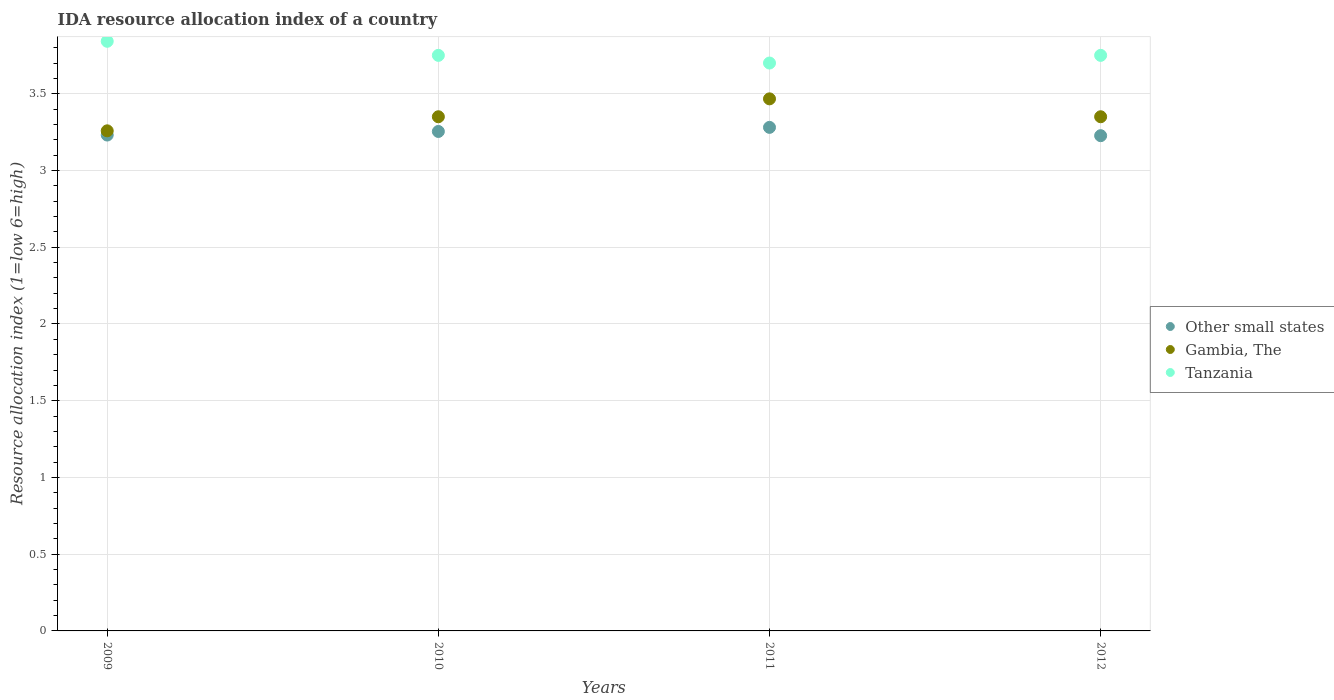Is the number of dotlines equal to the number of legend labels?
Make the answer very short. Yes. What is the IDA resource allocation index in Other small states in 2012?
Offer a terse response. 3.23. Across all years, what is the maximum IDA resource allocation index in Other small states?
Offer a terse response. 3.28. Across all years, what is the minimum IDA resource allocation index in Gambia, The?
Your response must be concise. 3.26. In which year was the IDA resource allocation index in Gambia, The maximum?
Your answer should be compact. 2011. What is the total IDA resource allocation index in Gambia, The in the graph?
Your response must be concise. 13.43. What is the difference between the IDA resource allocation index in Other small states in 2010 and that in 2012?
Provide a succinct answer. 0.03. What is the difference between the IDA resource allocation index in Gambia, The in 2011 and the IDA resource allocation index in Other small states in 2012?
Your response must be concise. 0.24. What is the average IDA resource allocation index in Other small states per year?
Make the answer very short. 3.25. In the year 2010, what is the difference between the IDA resource allocation index in Tanzania and IDA resource allocation index in Other small states?
Keep it short and to the point. 0.5. In how many years, is the IDA resource allocation index in Gambia, The greater than 3.5?
Provide a short and direct response. 0. What is the ratio of the IDA resource allocation index in Tanzania in 2009 to that in 2011?
Your answer should be compact. 1.04. Is the IDA resource allocation index in Tanzania in 2011 less than that in 2012?
Keep it short and to the point. Yes. Is the difference between the IDA resource allocation index in Tanzania in 2009 and 2012 greater than the difference between the IDA resource allocation index in Other small states in 2009 and 2012?
Provide a short and direct response. Yes. What is the difference between the highest and the second highest IDA resource allocation index in Gambia, The?
Your answer should be very brief. 0.12. What is the difference between the highest and the lowest IDA resource allocation index in Tanzania?
Keep it short and to the point. 0.14. In how many years, is the IDA resource allocation index in Other small states greater than the average IDA resource allocation index in Other small states taken over all years?
Keep it short and to the point. 2. Is it the case that in every year, the sum of the IDA resource allocation index in Tanzania and IDA resource allocation index in Other small states  is greater than the IDA resource allocation index in Gambia, The?
Keep it short and to the point. Yes. Is the IDA resource allocation index in Other small states strictly greater than the IDA resource allocation index in Tanzania over the years?
Offer a very short reply. No. Is the IDA resource allocation index in Other small states strictly less than the IDA resource allocation index in Gambia, The over the years?
Offer a very short reply. Yes. How many dotlines are there?
Your answer should be compact. 3. How many years are there in the graph?
Give a very brief answer. 4. What is the difference between two consecutive major ticks on the Y-axis?
Make the answer very short. 0.5. Are the values on the major ticks of Y-axis written in scientific E-notation?
Offer a very short reply. No. Does the graph contain any zero values?
Make the answer very short. No. Where does the legend appear in the graph?
Offer a terse response. Center right. How many legend labels are there?
Make the answer very short. 3. How are the legend labels stacked?
Offer a terse response. Vertical. What is the title of the graph?
Keep it short and to the point. IDA resource allocation index of a country. Does "Pacific island small states" appear as one of the legend labels in the graph?
Your response must be concise. No. What is the label or title of the Y-axis?
Give a very brief answer. Resource allocation index (1=low 6=high). What is the Resource allocation index (1=low 6=high) of Other small states in 2009?
Give a very brief answer. 3.23. What is the Resource allocation index (1=low 6=high) of Gambia, The in 2009?
Ensure brevity in your answer.  3.26. What is the Resource allocation index (1=low 6=high) in Tanzania in 2009?
Keep it short and to the point. 3.84. What is the Resource allocation index (1=low 6=high) in Other small states in 2010?
Provide a short and direct response. 3.25. What is the Resource allocation index (1=low 6=high) of Gambia, The in 2010?
Make the answer very short. 3.35. What is the Resource allocation index (1=low 6=high) in Tanzania in 2010?
Offer a very short reply. 3.75. What is the Resource allocation index (1=low 6=high) in Other small states in 2011?
Offer a terse response. 3.28. What is the Resource allocation index (1=low 6=high) of Gambia, The in 2011?
Provide a short and direct response. 3.47. What is the Resource allocation index (1=low 6=high) of Tanzania in 2011?
Offer a terse response. 3.7. What is the Resource allocation index (1=low 6=high) of Other small states in 2012?
Make the answer very short. 3.23. What is the Resource allocation index (1=low 6=high) of Gambia, The in 2012?
Your answer should be compact. 3.35. What is the Resource allocation index (1=low 6=high) in Tanzania in 2012?
Ensure brevity in your answer.  3.75. Across all years, what is the maximum Resource allocation index (1=low 6=high) in Other small states?
Make the answer very short. 3.28. Across all years, what is the maximum Resource allocation index (1=low 6=high) in Gambia, The?
Make the answer very short. 3.47. Across all years, what is the maximum Resource allocation index (1=low 6=high) of Tanzania?
Ensure brevity in your answer.  3.84. Across all years, what is the minimum Resource allocation index (1=low 6=high) in Other small states?
Provide a succinct answer. 3.23. Across all years, what is the minimum Resource allocation index (1=low 6=high) in Gambia, The?
Keep it short and to the point. 3.26. What is the total Resource allocation index (1=low 6=high) in Other small states in the graph?
Offer a terse response. 12.99. What is the total Resource allocation index (1=low 6=high) of Gambia, The in the graph?
Give a very brief answer. 13.43. What is the total Resource allocation index (1=low 6=high) of Tanzania in the graph?
Offer a terse response. 15.04. What is the difference between the Resource allocation index (1=low 6=high) in Other small states in 2009 and that in 2010?
Ensure brevity in your answer.  -0.02. What is the difference between the Resource allocation index (1=low 6=high) of Gambia, The in 2009 and that in 2010?
Keep it short and to the point. -0.09. What is the difference between the Resource allocation index (1=low 6=high) in Tanzania in 2009 and that in 2010?
Ensure brevity in your answer.  0.09. What is the difference between the Resource allocation index (1=low 6=high) of Other small states in 2009 and that in 2011?
Your response must be concise. -0.05. What is the difference between the Resource allocation index (1=low 6=high) in Gambia, The in 2009 and that in 2011?
Give a very brief answer. -0.21. What is the difference between the Resource allocation index (1=low 6=high) in Tanzania in 2009 and that in 2011?
Keep it short and to the point. 0.14. What is the difference between the Resource allocation index (1=low 6=high) of Other small states in 2009 and that in 2012?
Make the answer very short. 0. What is the difference between the Resource allocation index (1=low 6=high) of Gambia, The in 2009 and that in 2012?
Offer a terse response. -0.09. What is the difference between the Resource allocation index (1=low 6=high) in Tanzania in 2009 and that in 2012?
Your response must be concise. 0.09. What is the difference between the Resource allocation index (1=low 6=high) in Other small states in 2010 and that in 2011?
Offer a terse response. -0.03. What is the difference between the Resource allocation index (1=low 6=high) in Gambia, The in 2010 and that in 2011?
Keep it short and to the point. -0.12. What is the difference between the Resource allocation index (1=low 6=high) of Tanzania in 2010 and that in 2011?
Your response must be concise. 0.05. What is the difference between the Resource allocation index (1=low 6=high) of Other small states in 2010 and that in 2012?
Your answer should be very brief. 0.03. What is the difference between the Resource allocation index (1=low 6=high) in Other small states in 2011 and that in 2012?
Ensure brevity in your answer.  0.05. What is the difference between the Resource allocation index (1=low 6=high) in Gambia, The in 2011 and that in 2012?
Offer a terse response. 0.12. What is the difference between the Resource allocation index (1=low 6=high) in Tanzania in 2011 and that in 2012?
Your answer should be very brief. -0.05. What is the difference between the Resource allocation index (1=low 6=high) in Other small states in 2009 and the Resource allocation index (1=low 6=high) in Gambia, The in 2010?
Ensure brevity in your answer.  -0.12. What is the difference between the Resource allocation index (1=low 6=high) of Other small states in 2009 and the Resource allocation index (1=low 6=high) of Tanzania in 2010?
Offer a terse response. -0.52. What is the difference between the Resource allocation index (1=low 6=high) of Gambia, The in 2009 and the Resource allocation index (1=low 6=high) of Tanzania in 2010?
Offer a terse response. -0.49. What is the difference between the Resource allocation index (1=low 6=high) in Other small states in 2009 and the Resource allocation index (1=low 6=high) in Gambia, The in 2011?
Give a very brief answer. -0.24. What is the difference between the Resource allocation index (1=low 6=high) of Other small states in 2009 and the Resource allocation index (1=low 6=high) of Tanzania in 2011?
Offer a very short reply. -0.47. What is the difference between the Resource allocation index (1=low 6=high) in Gambia, The in 2009 and the Resource allocation index (1=low 6=high) in Tanzania in 2011?
Make the answer very short. -0.44. What is the difference between the Resource allocation index (1=low 6=high) in Other small states in 2009 and the Resource allocation index (1=low 6=high) in Gambia, The in 2012?
Your answer should be very brief. -0.12. What is the difference between the Resource allocation index (1=low 6=high) in Other small states in 2009 and the Resource allocation index (1=low 6=high) in Tanzania in 2012?
Ensure brevity in your answer.  -0.52. What is the difference between the Resource allocation index (1=low 6=high) in Gambia, The in 2009 and the Resource allocation index (1=low 6=high) in Tanzania in 2012?
Offer a very short reply. -0.49. What is the difference between the Resource allocation index (1=low 6=high) of Other small states in 2010 and the Resource allocation index (1=low 6=high) of Gambia, The in 2011?
Give a very brief answer. -0.21. What is the difference between the Resource allocation index (1=low 6=high) of Other small states in 2010 and the Resource allocation index (1=low 6=high) of Tanzania in 2011?
Offer a terse response. -0.45. What is the difference between the Resource allocation index (1=low 6=high) of Gambia, The in 2010 and the Resource allocation index (1=low 6=high) of Tanzania in 2011?
Keep it short and to the point. -0.35. What is the difference between the Resource allocation index (1=low 6=high) in Other small states in 2010 and the Resource allocation index (1=low 6=high) in Gambia, The in 2012?
Your response must be concise. -0.1. What is the difference between the Resource allocation index (1=low 6=high) in Other small states in 2010 and the Resource allocation index (1=low 6=high) in Tanzania in 2012?
Offer a very short reply. -0.5. What is the difference between the Resource allocation index (1=low 6=high) of Gambia, The in 2010 and the Resource allocation index (1=low 6=high) of Tanzania in 2012?
Your response must be concise. -0.4. What is the difference between the Resource allocation index (1=low 6=high) of Other small states in 2011 and the Resource allocation index (1=low 6=high) of Gambia, The in 2012?
Give a very brief answer. -0.07. What is the difference between the Resource allocation index (1=low 6=high) of Other small states in 2011 and the Resource allocation index (1=low 6=high) of Tanzania in 2012?
Provide a short and direct response. -0.47. What is the difference between the Resource allocation index (1=low 6=high) of Gambia, The in 2011 and the Resource allocation index (1=low 6=high) of Tanzania in 2012?
Provide a short and direct response. -0.28. What is the average Resource allocation index (1=low 6=high) of Other small states per year?
Keep it short and to the point. 3.25. What is the average Resource allocation index (1=low 6=high) of Gambia, The per year?
Ensure brevity in your answer.  3.36. What is the average Resource allocation index (1=low 6=high) in Tanzania per year?
Your answer should be very brief. 3.76. In the year 2009, what is the difference between the Resource allocation index (1=low 6=high) in Other small states and Resource allocation index (1=low 6=high) in Gambia, The?
Your response must be concise. -0.03. In the year 2009, what is the difference between the Resource allocation index (1=low 6=high) in Other small states and Resource allocation index (1=low 6=high) in Tanzania?
Keep it short and to the point. -0.61. In the year 2009, what is the difference between the Resource allocation index (1=low 6=high) of Gambia, The and Resource allocation index (1=low 6=high) of Tanzania?
Your response must be concise. -0.58. In the year 2010, what is the difference between the Resource allocation index (1=low 6=high) in Other small states and Resource allocation index (1=low 6=high) in Gambia, The?
Offer a very short reply. -0.1. In the year 2010, what is the difference between the Resource allocation index (1=low 6=high) of Other small states and Resource allocation index (1=low 6=high) of Tanzania?
Your response must be concise. -0.5. In the year 2010, what is the difference between the Resource allocation index (1=low 6=high) of Gambia, The and Resource allocation index (1=low 6=high) of Tanzania?
Make the answer very short. -0.4. In the year 2011, what is the difference between the Resource allocation index (1=low 6=high) in Other small states and Resource allocation index (1=low 6=high) in Gambia, The?
Offer a very short reply. -0.19. In the year 2011, what is the difference between the Resource allocation index (1=low 6=high) of Other small states and Resource allocation index (1=low 6=high) of Tanzania?
Make the answer very short. -0.42. In the year 2011, what is the difference between the Resource allocation index (1=low 6=high) of Gambia, The and Resource allocation index (1=low 6=high) of Tanzania?
Your response must be concise. -0.23. In the year 2012, what is the difference between the Resource allocation index (1=low 6=high) in Other small states and Resource allocation index (1=low 6=high) in Gambia, The?
Offer a terse response. -0.12. In the year 2012, what is the difference between the Resource allocation index (1=low 6=high) of Other small states and Resource allocation index (1=low 6=high) of Tanzania?
Provide a succinct answer. -0.52. In the year 2012, what is the difference between the Resource allocation index (1=low 6=high) in Gambia, The and Resource allocation index (1=low 6=high) in Tanzania?
Make the answer very short. -0.4. What is the ratio of the Resource allocation index (1=low 6=high) in Other small states in 2009 to that in 2010?
Give a very brief answer. 0.99. What is the ratio of the Resource allocation index (1=low 6=high) in Gambia, The in 2009 to that in 2010?
Offer a very short reply. 0.97. What is the ratio of the Resource allocation index (1=low 6=high) in Tanzania in 2009 to that in 2010?
Provide a succinct answer. 1.02. What is the ratio of the Resource allocation index (1=low 6=high) of Gambia, The in 2009 to that in 2011?
Make the answer very short. 0.94. What is the ratio of the Resource allocation index (1=low 6=high) in Tanzania in 2009 to that in 2011?
Provide a short and direct response. 1.04. What is the ratio of the Resource allocation index (1=low 6=high) in Other small states in 2009 to that in 2012?
Your response must be concise. 1. What is the ratio of the Resource allocation index (1=low 6=high) in Gambia, The in 2009 to that in 2012?
Your response must be concise. 0.97. What is the ratio of the Resource allocation index (1=low 6=high) of Tanzania in 2009 to that in 2012?
Offer a very short reply. 1.02. What is the ratio of the Resource allocation index (1=low 6=high) of Gambia, The in 2010 to that in 2011?
Your answer should be compact. 0.97. What is the ratio of the Resource allocation index (1=low 6=high) of Tanzania in 2010 to that in 2011?
Give a very brief answer. 1.01. What is the ratio of the Resource allocation index (1=low 6=high) in Other small states in 2010 to that in 2012?
Make the answer very short. 1.01. What is the ratio of the Resource allocation index (1=low 6=high) of Other small states in 2011 to that in 2012?
Give a very brief answer. 1.02. What is the ratio of the Resource allocation index (1=low 6=high) in Gambia, The in 2011 to that in 2012?
Make the answer very short. 1.03. What is the ratio of the Resource allocation index (1=low 6=high) in Tanzania in 2011 to that in 2012?
Your answer should be very brief. 0.99. What is the difference between the highest and the second highest Resource allocation index (1=low 6=high) of Other small states?
Offer a very short reply. 0.03. What is the difference between the highest and the second highest Resource allocation index (1=low 6=high) in Gambia, The?
Your answer should be compact. 0.12. What is the difference between the highest and the second highest Resource allocation index (1=low 6=high) of Tanzania?
Make the answer very short. 0.09. What is the difference between the highest and the lowest Resource allocation index (1=low 6=high) of Other small states?
Keep it short and to the point. 0.05. What is the difference between the highest and the lowest Resource allocation index (1=low 6=high) in Gambia, The?
Ensure brevity in your answer.  0.21. What is the difference between the highest and the lowest Resource allocation index (1=low 6=high) of Tanzania?
Your answer should be very brief. 0.14. 